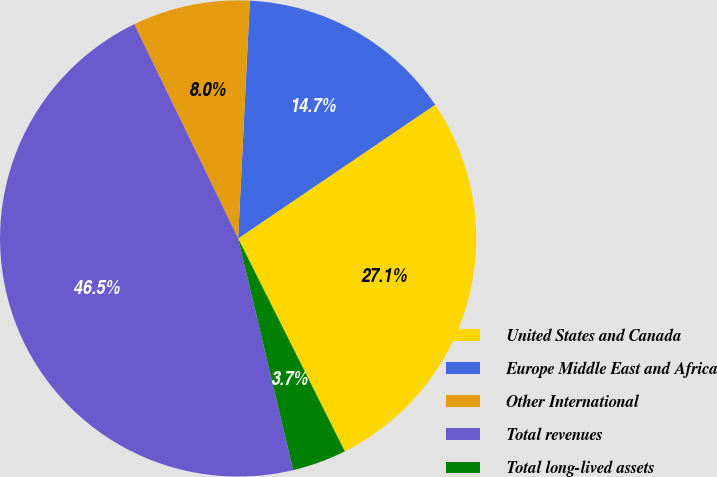Convert chart. <chart><loc_0><loc_0><loc_500><loc_500><pie_chart><fcel>United States and Canada<fcel>Europe Middle East and Africa<fcel>Other International<fcel>Total revenues<fcel>Total long-lived assets<nl><fcel>27.1%<fcel>14.73%<fcel>7.97%<fcel>46.53%<fcel>3.68%<nl></chart> 